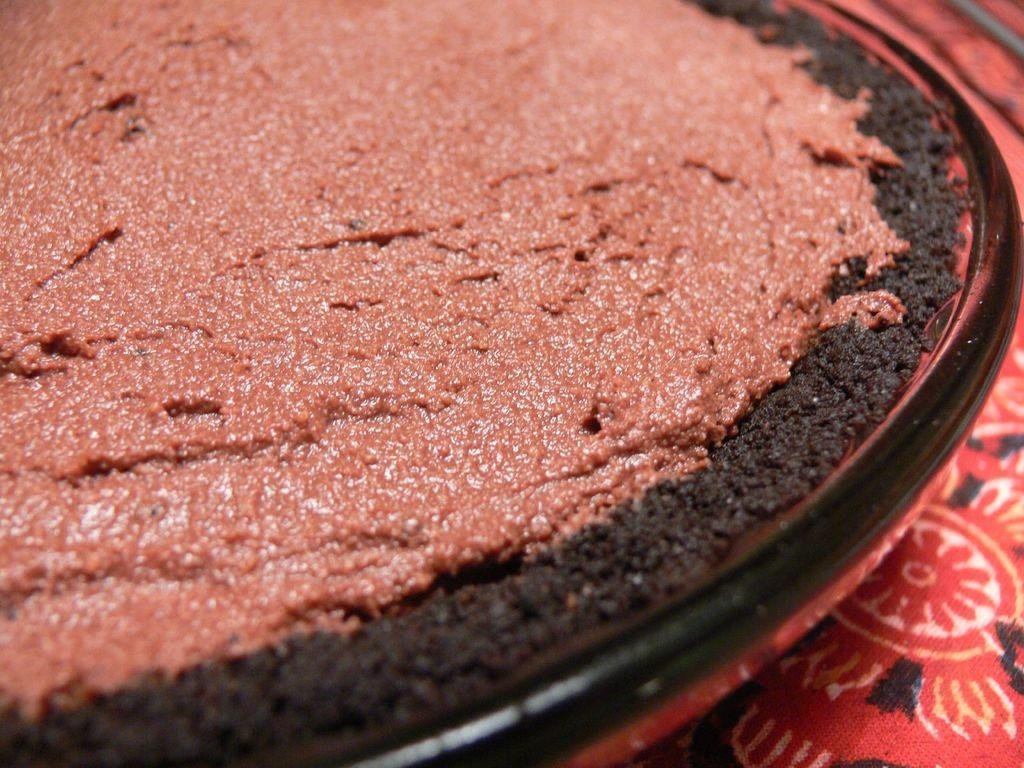What is on the plate that is visible in the image? There is food in a plate in the image. What else can be seen in the image besides the plate of food? There is a cloth visible in the image. What type of notebook is lying on the plate in the image? There is no notebook present in the image; it only features a plate of food and a cloth. 